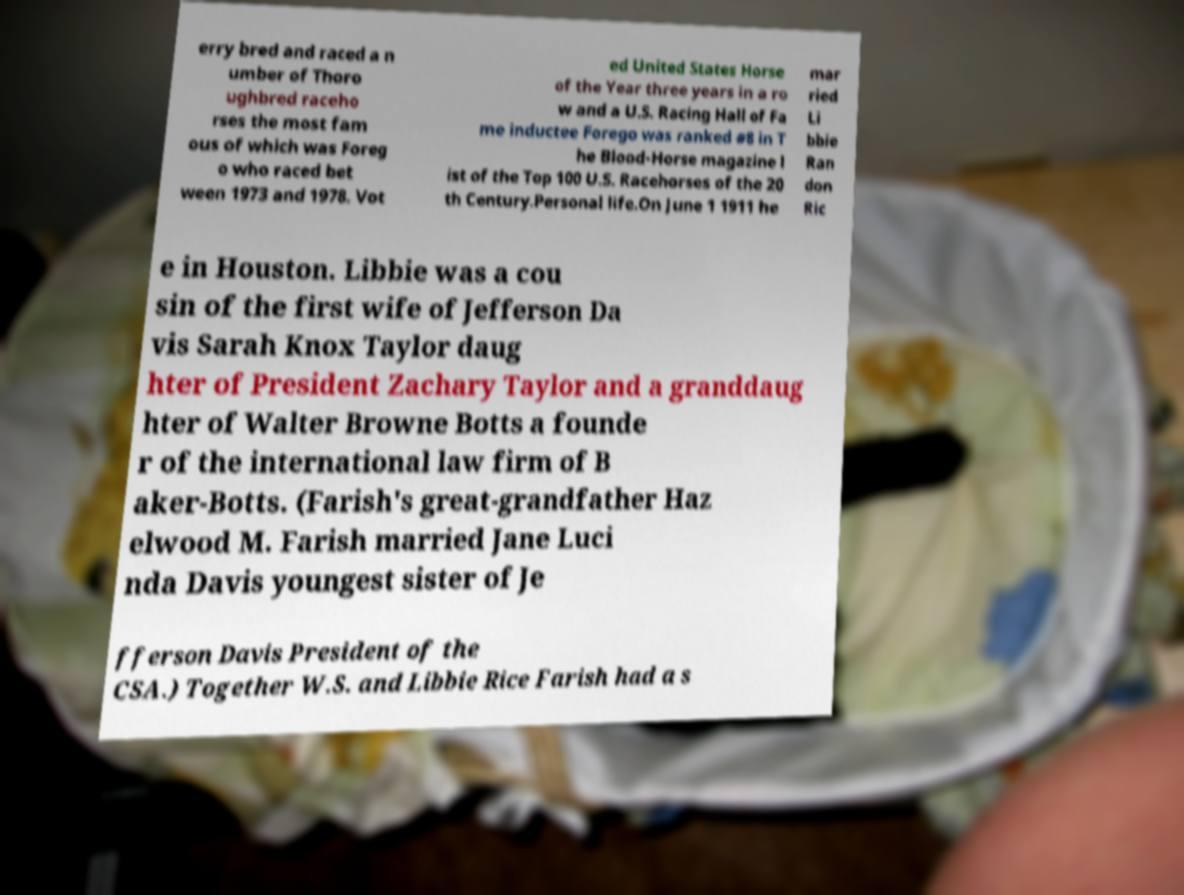Please read and relay the text visible in this image. What does it say? erry bred and raced a n umber of Thoro ughbred raceho rses the most fam ous of which was Foreg o who raced bet ween 1973 and 1978. Vot ed United States Horse of the Year three years in a ro w and a U.S. Racing Hall of Fa me inductee Forego was ranked #8 in T he Blood-Horse magazine l ist of the Top 100 U.S. Racehorses of the 20 th Century.Personal life.On June 1 1911 he mar ried Li bbie Ran don Ric e in Houston. Libbie was a cou sin of the first wife of Jefferson Da vis Sarah Knox Taylor daug hter of President Zachary Taylor and a granddaug hter of Walter Browne Botts a founde r of the international law firm of B aker-Botts. (Farish's great-grandfather Haz elwood M. Farish married Jane Luci nda Davis youngest sister of Je fferson Davis President of the CSA.) Together W.S. and Libbie Rice Farish had a s 